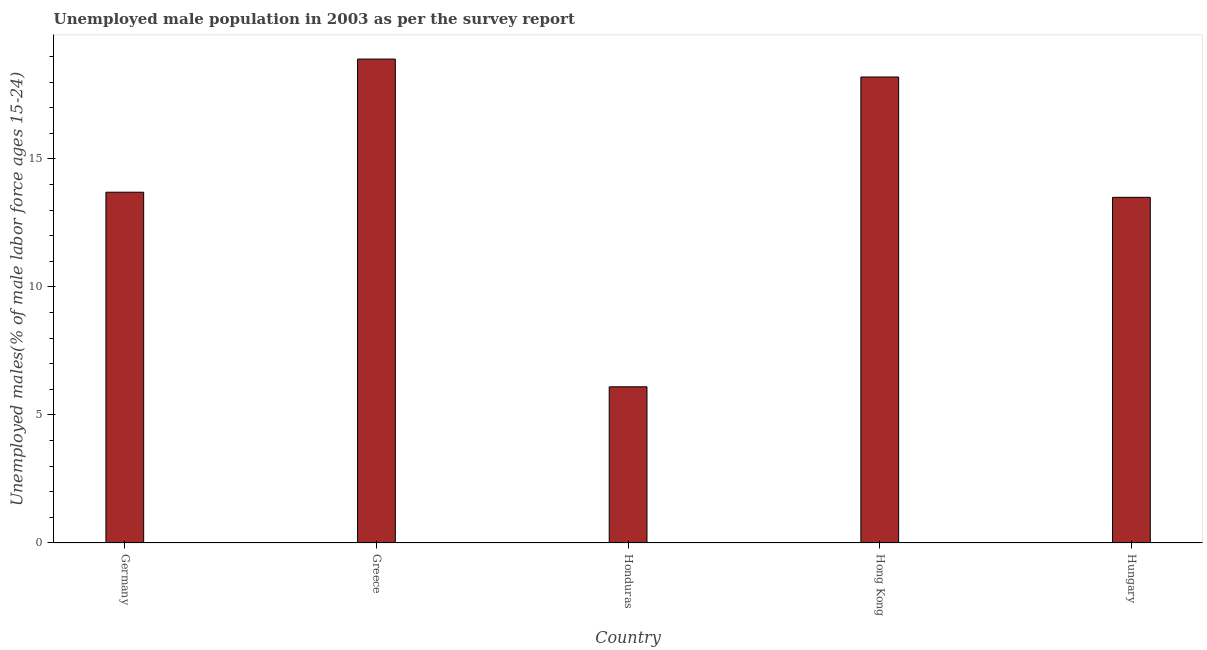Does the graph contain grids?
Ensure brevity in your answer.  No. What is the title of the graph?
Your answer should be compact. Unemployed male population in 2003 as per the survey report. What is the label or title of the X-axis?
Ensure brevity in your answer.  Country. What is the label or title of the Y-axis?
Your response must be concise. Unemployed males(% of male labor force ages 15-24). What is the unemployed male youth in Hong Kong?
Keep it short and to the point. 18.2. Across all countries, what is the maximum unemployed male youth?
Make the answer very short. 18.9. Across all countries, what is the minimum unemployed male youth?
Offer a terse response. 6.1. In which country was the unemployed male youth maximum?
Offer a very short reply. Greece. In which country was the unemployed male youth minimum?
Your response must be concise. Honduras. What is the sum of the unemployed male youth?
Provide a succinct answer. 70.4. What is the difference between the unemployed male youth in Honduras and Hungary?
Your answer should be compact. -7.4. What is the average unemployed male youth per country?
Make the answer very short. 14.08. What is the median unemployed male youth?
Provide a short and direct response. 13.7. In how many countries, is the unemployed male youth greater than 17 %?
Your answer should be very brief. 2. Is the difference between the unemployed male youth in Greece and Hungary greater than the difference between any two countries?
Give a very brief answer. No. Is the sum of the unemployed male youth in Germany and Honduras greater than the maximum unemployed male youth across all countries?
Provide a succinct answer. Yes. How many bars are there?
Give a very brief answer. 5. Are all the bars in the graph horizontal?
Provide a short and direct response. No. What is the difference between two consecutive major ticks on the Y-axis?
Provide a succinct answer. 5. Are the values on the major ticks of Y-axis written in scientific E-notation?
Offer a very short reply. No. What is the Unemployed males(% of male labor force ages 15-24) of Germany?
Offer a very short reply. 13.7. What is the Unemployed males(% of male labor force ages 15-24) of Greece?
Ensure brevity in your answer.  18.9. What is the Unemployed males(% of male labor force ages 15-24) of Honduras?
Keep it short and to the point. 6.1. What is the Unemployed males(% of male labor force ages 15-24) of Hong Kong?
Provide a short and direct response. 18.2. What is the Unemployed males(% of male labor force ages 15-24) of Hungary?
Your answer should be compact. 13.5. What is the difference between the Unemployed males(% of male labor force ages 15-24) in Germany and Greece?
Keep it short and to the point. -5.2. What is the difference between the Unemployed males(% of male labor force ages 15-24) in Germany and Honduras?
Provide a short and direct response. 7.6. What is the difference between the Unemployed males(% of male labor force ages 15-24) in Germany and Hong Kong?
Your response must be concise. -4.5. What is the difference between the Unemployed males(% of male labor force ages 15-24) in Greece and Honduras?
Keep it short and to the point. 12.8. What is the difference between the Unemployed males(% of male labor force ages 15-24) in Greece and Hong Kong?
Keep it short and to the point. 0.7. What is the difference between the Unemployed males(% of male labor force ages 15-24) in Honduras and Hong Kong?
Make the answer very short. -12.1. What is the difference between the Unemployed males(% of male labor force ages 15-24) in Honduras and Hungary?
Your response must be concise. -7.4. What is the ratio of the Unemployed males(% of male labor force ages 15-24) in Germany to that in Greece?
Offer a very short reply. 0.72. What is the ratio of the Unemployed males(% of male labor force ages 15-24) in Germany to that in Honduras?
Ensure brevity in your answer.  2.25. What is the ratio of the Unemployed males(% of male labor force ages 15-24) in Germany to that in Hong Kong?
Keep it short and to the point. 0.75. What is the ratio of the Unemployed males(% of male labor force ages 15-24) in Germany to that in Hungary?
Provide a succinct answer. 1.01. What is the ratio of the Unemployed males(% of male labor force ages 15-24) in Greece to that in Honduras?
Your response must be concise. 3.1. What is the ratio of the Unemployed males(% of male labor force ages 15-24) in Greece to that in Hong Kong?
Your answer should be very brief. 1.04. What is the ratio of the Unemployed males(% of male labor force ages 15-24) in Greece to that in Hungary?
Your answer should be very brief. 1.4. What is the ratio of the Unemployed males(% of male labor force ages 15-24) in Honduras to that in Hong Kong?
Keep it short and to the point. 0.34. What is the ratio of the Unemployed males(% of male labor force ages 15-24) in Honduras to that in Hungary?
Your answer should be compact. 0.45. What is the ratio of the Unemployed males(% of male labor force ages 15-24) in Hong Kong to that in Hungary?
Your answer should be compact. 1.35. 